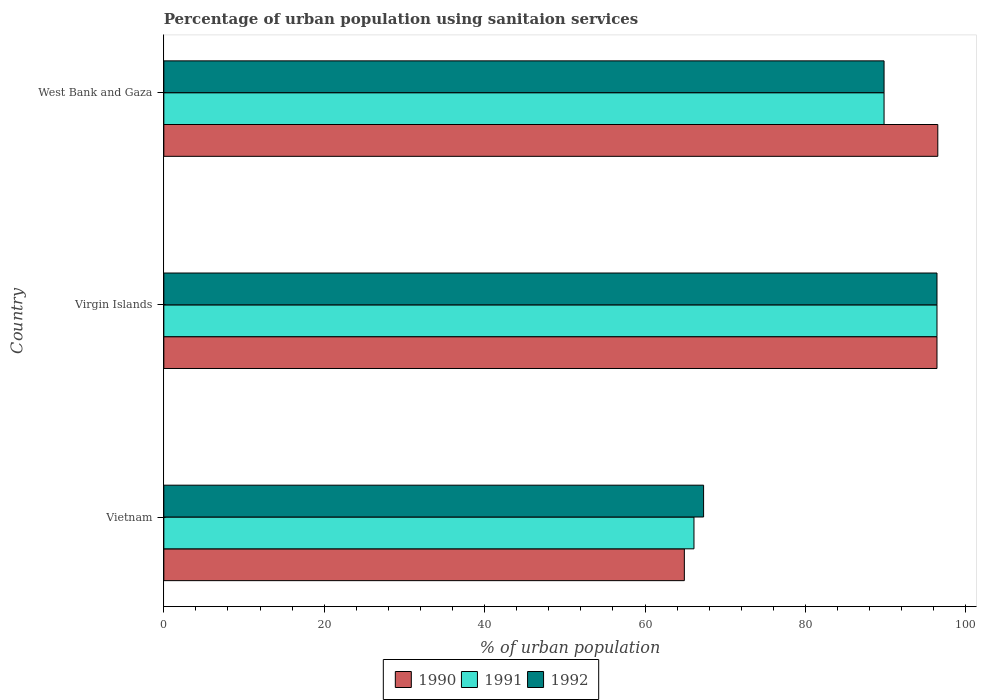How many bars are there on the 2nd tick from the top?
Make the answer very short. 3. How many bars are there on the 1st tick from the bottom?
Your answer should be very brief. 3. What is the label of the 1st group of bars from the top?
Offer a very short reply. West Bank and Gaza. What is the percentage of urban population using sanitaion services in 1992 in West Bank and Gaza?
Offer a very short reply. 89.8. Across all countries, what is the maximum percentage of urban population using sanitaion services in 1990?
Provide a short and direct response. 96.5. Across all countries, what is the minimum percentage of urban population using sanitaion services in 1991?
Offer a terse response. 66.1. In which country was the percentage of urban population using sanitaion services in 1992 maximum?
Your answer should be very brief. Virgin Islands. In which country was the percentage of urban population using sanitaion services in 1992 minimum?
Your answer should be compact. Vietnam. What is the total percentage of urban population using sanitaion services in 1990 in the graph?
Keep it short and to the point. 257.8. What is the difference between the percentage of urban population using sanitaion services in 1991 in Virgin Islands and that in West Bank and Gaza?
Provide a succinct answer. 6.6. What is the difference between the percentage of urban population using sanitaion services in 1991 in Virgin Islands and the percentage of urban population using sanitaion services in 1990 in West Bank and Gaza?
Your answer should be very brief. -0.1. What is the average percentage of urban population using sanitaion services in 1990 per country?
Ensure brevity in your answer.  85.93. What is the difference between the percentage of urban population using sanitaion services in 1990 and percentage of urban population using sanitaion services in 1992 in Vietnam?
Your answer should be compact. -2.4. In how many countries, is the percentage of urban population using sanitaion services in 1991 greater than 48 %?
Offer a terse response. 3. What is the ratio of the percentage of urban population using sanitaion services in 1990 in Vietnam to that in Virgin Islands?
Your response must be concise. 0.67. Is the percentage of urban population using sanitaion services in 1991 in Virgin Islands less than that in West Bank and Gaza?
Make the answer very short. No. What is the difference between the highest and the second highest percentage of urban population using sanitaion services in 1990?
Ensure brevity in your answer.  0.1. What is the difference between the highest and the lowest percentage of urban population using sanitaion services in 1990?
Provide a succinct answer. 31.6. Is it the case that in every country, the sum of the percentage of urban population using sanitaion services in 1992 and percentage of urban population using sanitaion services in 1991 is greater than the percentage of urban population using sanitaion services in 1990?
Give a very brief answer. Yes. How many countries are there in the graph?
Give a very brief answer. 3. Does the graph contain any zero values?
Provide a short and direct response. No. Where does the legend appear in the graph?
Your response must be concise. Bottom center. How many legend labels are there?
Your answer should be compact. 3. How are the legend labels stacked?
Provide a succinct answer. Horizontal. What is the title of the graph?
Offer a very short reply. Percentage of urban population using sanitaion services. What is the label or title of the X-axis?
Provide a succinct answer. % of urban population. What is the label or title of the Y-axis?
Offer a terse response. Country. What is the % of urban population of 1990 in Vietnam?
Offer a terse response. 64.9. What is the % of urban population of 1991 in Vietnam?
Ensure brevity in your answer.  66.1. What is the % of urban population in 1992 in Vietnam?
Provide a succinct answer. 67.3. What is the % of urban population in 1990 in Virgin Islands?
Ensure brevity in your answer.  96.4. What is the % of urban population in 1991 in Virgin Islands?
Provide a succinct answer. 96.4. What is the % of urban population of 1992 in Virgin Islands?
Your answer should be compact. 96.4. What is the % of urban population in 1990 in West Bank and Gaza?
Your response must be concise. 96.5. What is the % of urban population in 1991 in West Bank and Gaza?
Provide a succinct answer. 89.8. What is the % of urban population of 1992 in West Bank and Gaza?
Provide a succinct answer. 89.8. Across all countries, what is the maximum % of urban population in 1990?
Provide a succinct answer. 96.5. Across all countries, what is the maximum % of urban population of 1991?
Keep it short and to the point. 96.4. Across all countries, what is the maximum % of urban population of 1992?
Your answer should be compact. 96.4. Across all countries, what is the minimum % of urban population in 1990?
Provide a succinct answer. 64.9. Across all countries, what is the minimum % of urban population in 1991?
Keep it short and to the point. 66.1. Across all countries, what is the minimum % of urban population of 1992?
Make the answer very short. 67.3. What is the total % of urban population in 1990 in the graph?
Your answer should be very brief. 257.8. What is the total % of urban population in 1991 in the graph?
Provide a succinct answer. 252.3. What is the total % of urban population of 1992 in the graph?
Provide a short and direct response. 253.5. What is the difference between the % of urban population in 1990 in Vietnam and that in Virgin Islands?
Make the answer very short. -31.5. What is the difference between the % of urban population in 1991 in Vietnam and that in Virgin Islands?
Your answer should be compact. -30.3. What is the difference between the % of urban population in 1992 in Vietnam and that in Virgin Islands?
Provide a short and direct response. -29.1. What is the difference between the % of urban population of 1990 in Vietnam and that in West Bank and Gaza?
Your answer should be compact. -31.6. What is the difference between the % of urban population of 1991 in Vietnam and that in West Bank and Gaza?
Your answer should be compact. -23.7. What is the difference between the % of urban population in 1992 in Vietnam and that in West Bank and Gaza?
Ensure brevity in your answer.  -22.5. What is the difference between the % of urban population of 1990 in Virgin Islands and that in West Bank and Gaza?
Offer a terse response. -0.1. What is the difference between the % of urban population in 1992 in Virgin Islands and that in West Bank and Gaza?
Give a very brief answer. 6.6. What is the difference between the % of urban population in 1990 in Vietnam and the % of urban population in 1991 in Virgin Islands?
Keep it short and to the point. -31.5. What is the difference between the % of urban population in 1990 in Vietnam and the % of urban population in 1992 in Virgin Islands?
Make the answer very short. -31.5. What is the difference between the % of urban population of 1991 in Vietnam and the % of urban population of 1992 in Virgin Islands?
Your response must be concise. -30.3. What is the difference between the % of urban population in 1990 in Vietnam and the % of urban population in 1991 in West Bank and Gaza?
Make the answer very short. -24.9. What is the difference between the % of urban population in 1990 in Vietnam and the % of urban population in 1992 in West Bank and Gaza?
Keep it short and to the point. -24.9. What is the difference between the % of urban population in 1991 in Vietnam and the % of urban population in 1992 in West Bank and Gaza?
Ensure brevity in your answer.  -23.7. What is the difference between the % of urban population of 1991 in Virgin Islands and the % of urban population of 1992 in West Bank and Gaza?
Make the answer very short. 6.6. What is the average % of urban population of 1990 per country?
Your answer should be very brief. 85.93. What is the average % of urban population in 1991 per country?
Make the answer very short. 84.1. What is the average % of urban population in 1992 per country?
Offer a very short reply. 84.5. What is the difference between the % of urban population of 1990 and % of urban population of 1991 in Vietnam?
Ensure brevity in your answer.  -1.2. What is the difference between the % of urban population of 1990 and % of urban population of 1992 in Vietnam?
Give a very brief answer. -2.4. What is the difference between the % of urban population of 1990 and % of urban population of 1991 in Virgin Islands?
Your response must be concise. 0. What is the ratio of the % of urban population of 1990 in Vietnam to that in Virgin Islands?
Your response must be concise. 0.67. What is the ratio of the % of urban population of 1991 in Vietnam to that in Virgin Islands?
Offer a terse response. 0.69. What is the ratio of the % of urban population of 1992 in Vietnam to that in Virgin Islands?
Offer a very short reply. 0.7. What is the ratio of the % of urban population of 1990 in Vietnam to that in West Bank and Gaza?
Make the answer very short. 0.67. What is the ratio of the % of urban population of 1991 in Vietnam to that in West Bank and Gaza?
Keep it short and to the point. 0.74. What is the ratio of the % of urban population in 1992 in Vietnam to that in West Bank and Gaza?
Offer a terse response. 0.75. What is the ratio of the % of urban population of 1990 in Virgin Islands to that in West Bank and Gaza?
Give a very brief answer. 1. What is the ratio of the % of urban population in 1991 in Virgin Islands to that in West Bank and Gaza?
Ensure brevity in your answer.  1.07. What is the ratio of the % of urban population in 1992 in Virgin Islands to that in West Bank and Gaza?
Your answer should be compact. 1.07. What is the difference between the highest and the lowest % of urban population of 1990?
Make the answer very short. 31.6. What is the difference between the highest and the lowest % of urban population of 1991?
Provide a short and direct response. 30.3. What is the difference between the highest and the lowest % of urban population in 1992?
Your answer should be very brief. 29.1. 